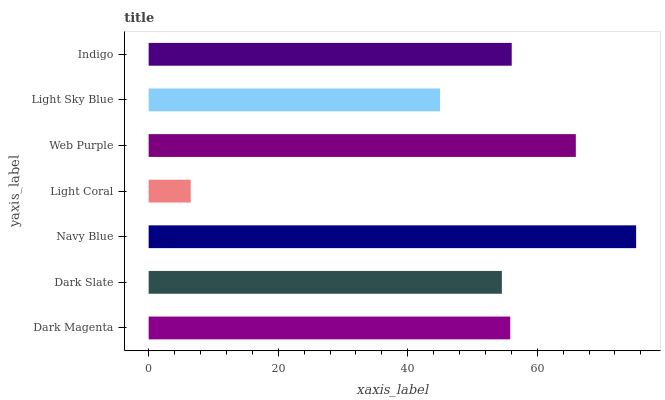Is Light Coral the minimum?
Answer yes or no. Yes. Is Navy Blue the maximum?
Answer yes or no. Yes. Is Dark Slate the minimum?
Answer yes or no. No. Is Dark Slate the maximum?
Answer yes or no. No. Is Dark Magenta greater than Dark Slate?
Answer yes or no. Yes. Is Dark Slate less than Dark Magenta?
Answer yes or no. Yes. Is Dark Slate greater than Dark Magenta?
Answer yes or no. No. Is Dark Magenta less than Dark Slate?
Answer yes or no. No. Is Dark Magenta the high median?
Answer yes or no. Yes. Is Dark Magenta the low median?
Answer yes or no. Yes. Is Dark Slate the high median?
Answer yes or no. No. Is Light Sky Blue the low median?
Answer yes or no. No. 